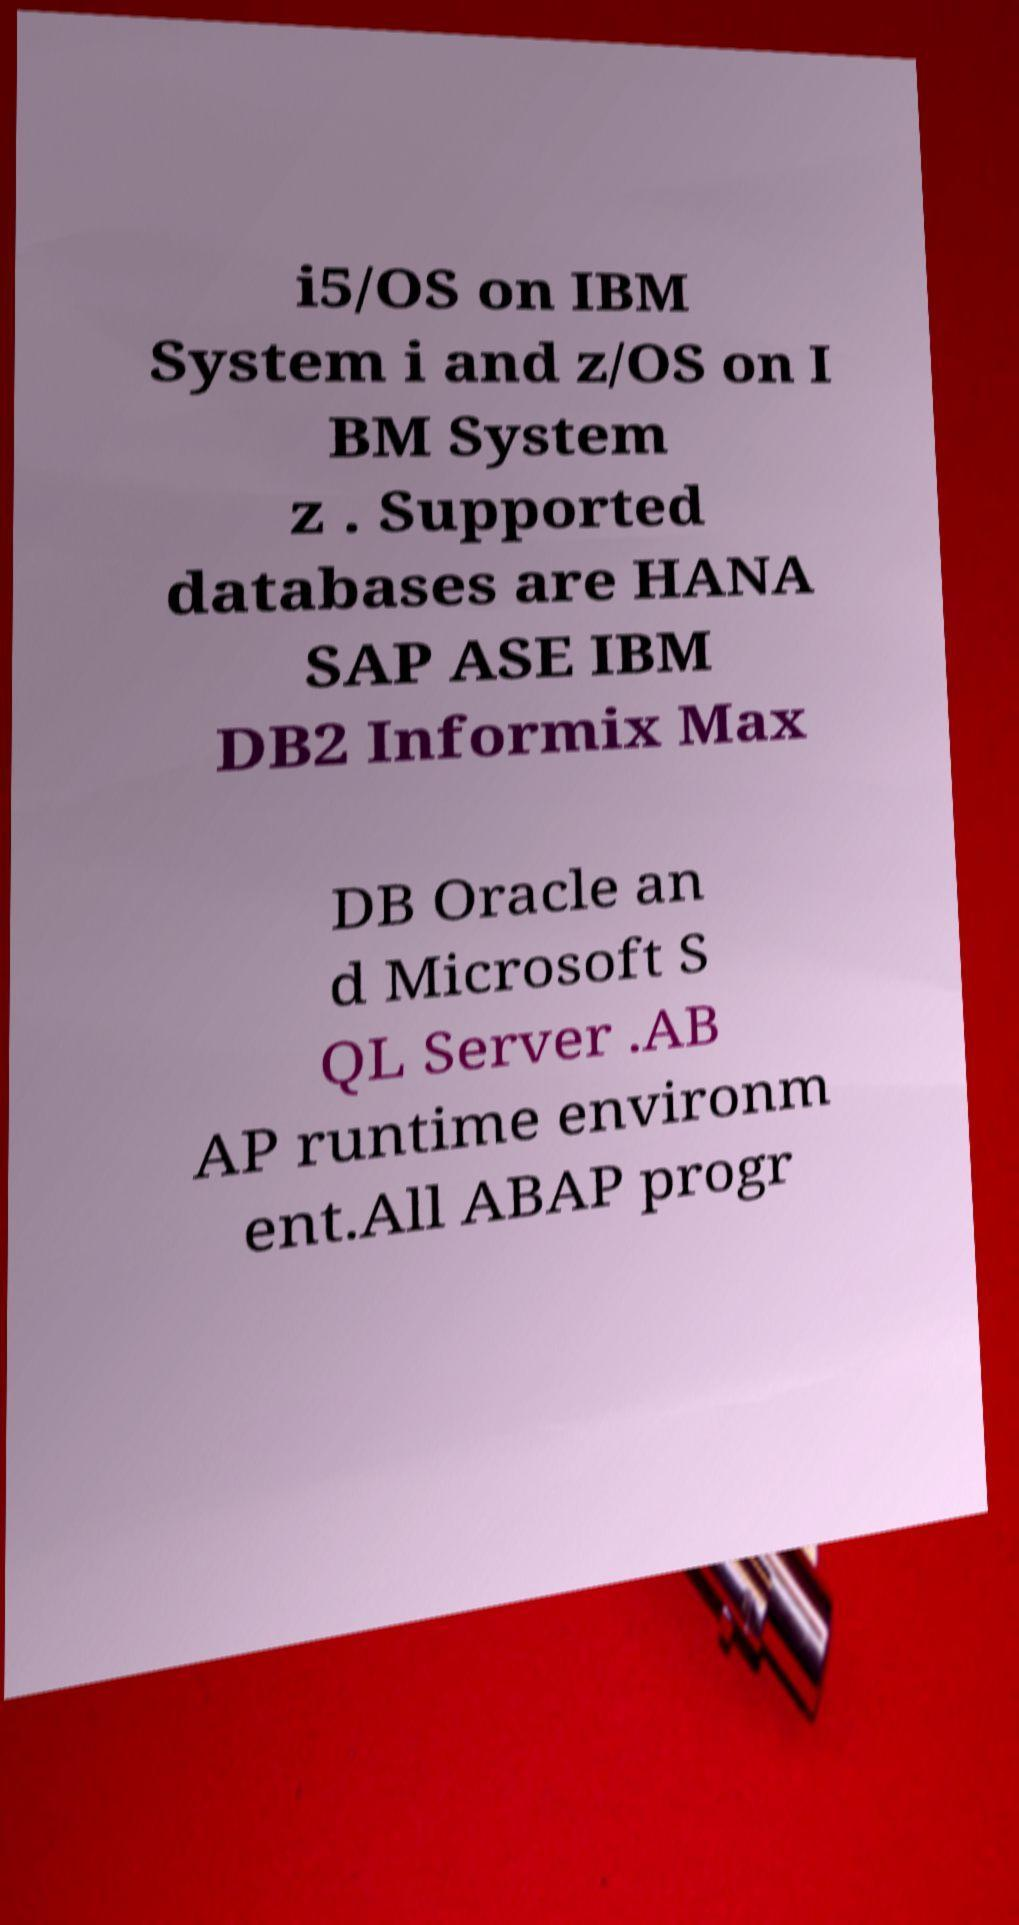Can you read and provide the text displayed in the image?This photo seems to have some interesting text. Can you extract and type it out for me? i5/OS on IBM System i and z/OS on I BM System z . Supported databases are HANA SAP ASE IBM DB2 Informix Max DB Oracle an d Microsoft S QL Server .AB AP runtime environm ent.All ABAP progr 